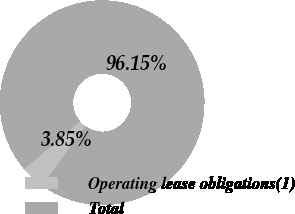Convert chart to OTSL. <chart><loc_0><loc_0><loc_500><loc_500><pie_chart><fcel>Operating lease obligations(1)<fcel>Total<nl><fcel>3.85%<fcel>96.15%<nl></chart> 